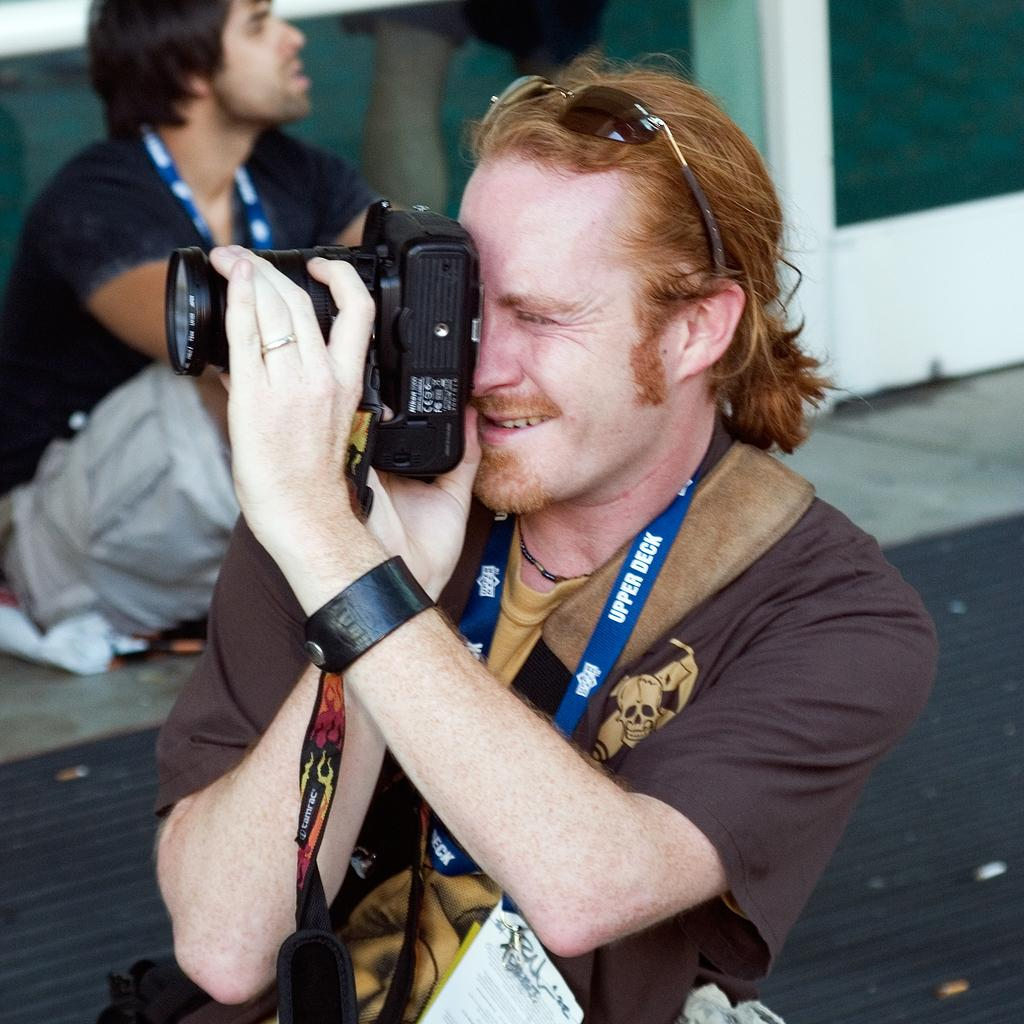What is the main subject in the middle of the image? There is a man in the middle of the image. What is the man in the middle wearing? The man in the middle is wearing a t-shirt and a tag. What is the man in the middle holding? The man in the middle is holding a camera. Can you describe the man in the background of the image? There is a man in the background of the image, and he is wearing a t-shirt and trousers. What type of eggs can be seen in the image? There are no eggs present in the image. Is there a fight happening between the two men in the image? There is no fight depicted in the image; the two men are simply standing in different positions. What reward is being given to the man in the middle for holding the camera? There is no reward mentioned or depicted in the image; the man is simply holding a camera. 